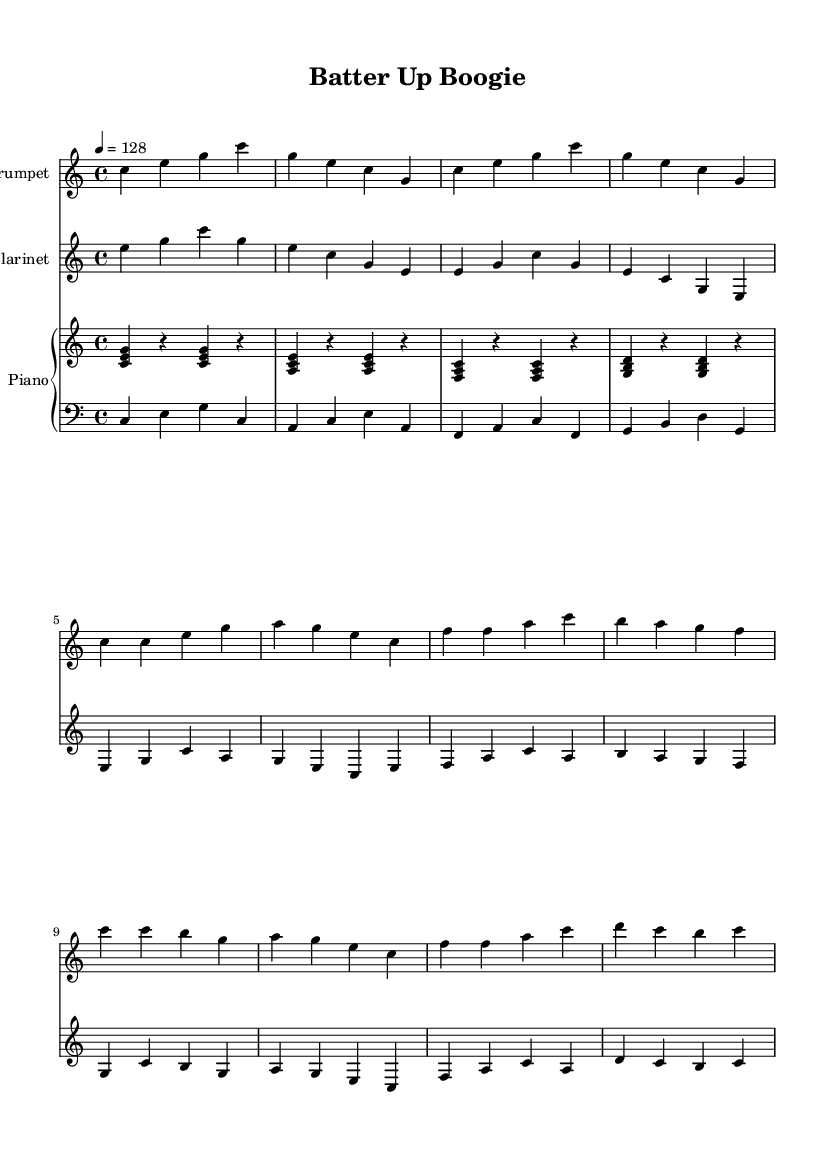What is the key signature of this music? The key signature is C major, which has no sharps or flats.
Answer: C major What is the time signature of this music? The time signature is indicated at the beginning of the score as 4/4, meaning four beats per measure.
Answer: 4/4 What is the tempo marking of this piece? The tempo marking is 128 beats per minute, specified in the score above the global music settings.
Answer: 128 How many measures are in the trumpet melody? The trumpet melody contains a total of 12 measures, evidenced by the counting of bars in the written part.
Answer: 12 What is the highest note played by the trumpet? The highest note played in the trumpet melody is C', shown in the final chorus section.
Answer: C' Which instrument plays the walking bass line? The walking bass line is performed by the bass staff, which is part of the piano setup in this score.
Answer: Bass What style of music does this piece belong to? The piece is an Electro-swing track, characterized by its fusion of electronic music elements with swing jazz rhythms.
Answer: Electro-swing 